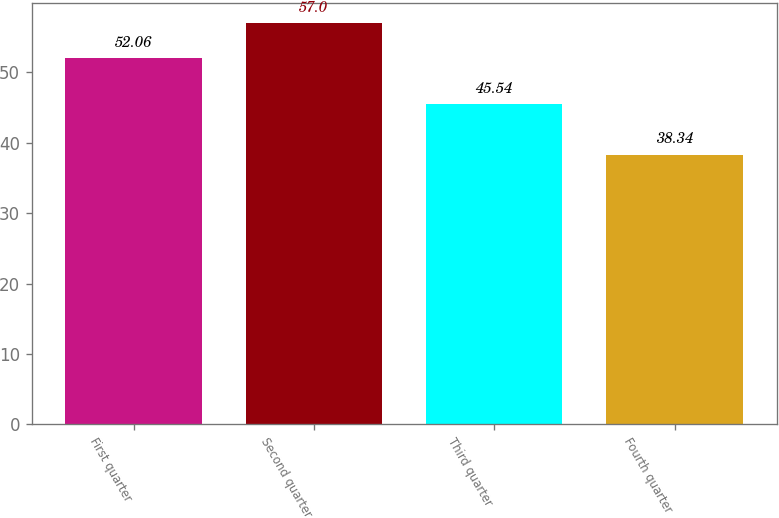<chart> <loc_0><loc_0><loc_500><loc_500><bar_chart><fcel>First quarter<fcel>Second quarter<fcel>Third quarter<fcel>Fourth quarter<nl><fcel>52.06<fcel>57<fcel>45.54<fcel>38.34<nl></chart> 